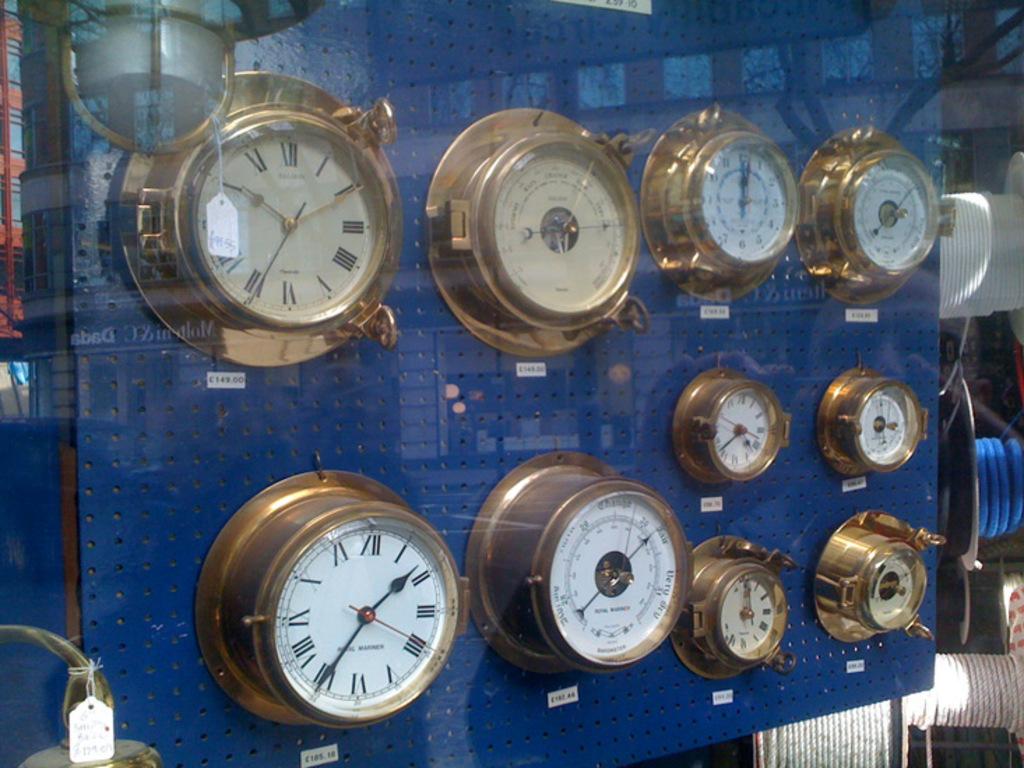What time is the clock on teh bottom left pointing to?
Provide a succinct answer. 1:35. 